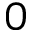<formula> <loc_0><loc_0><loc_500><loc_500>0</formula> 